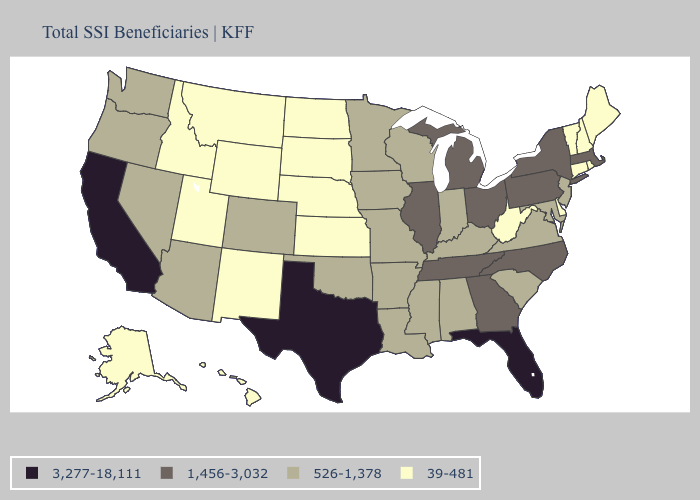Does Vermont have the highest value in the Northeast?
Write a very short answer. No. Name the states that have a value in the range 3,277-18,111?
Write a very short answer. California, Florida, Texas. What is the value of North Dakota?
Keep it brief. 39-481. What is the value of New York?
Answer briefly. 1,456-3,032. What is the highest value in states that border Massachusetts?
Short answer required. 1,456-3,032. Does Missouri have the highest value in the MidWest?
Be succinct. No. What is the highest value in the USA?
Write a very short answer. 3,277-18,111. Among the states that border New Jersey , which have the lowest value?
Be succinct. Delaware. What is the highest value in the USA?
Give a very brief answer. 3,277-18,111. Does Washington have the highest value in the West?
Write a very short answer. No. What is the highest value in states that border California?
Answer briefly. 526-1,378. Name the states that have a value in the range 3,277-18,111?
Be succinct. California, Florida, Texas. Which states hav the highest value in the Northeast?
Write a very short answer. Massachusetts, New York, Pennsylvania. What is the value of Ohio?
Keep it brief. 1,456-3,032. How many symbols are there in the legend?
Short answer required. 4. 